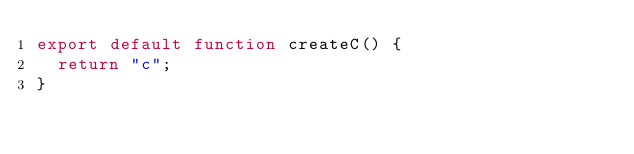Convert code to text. <code><loc_0><loc_0><loc_500><loc_500><_JavaScript_>export default function createC() {
	return "c";
}
</code> 